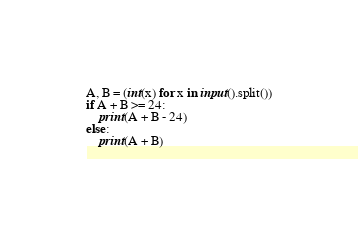Convert code to text. <code><loc_0><loc_0><loc_500><loc_500><_Python_>A, B = (int(x) for x in input().split())
if A + B >= 24:
    print(A + B - 24)
else:
    print(A + B)
</code> 